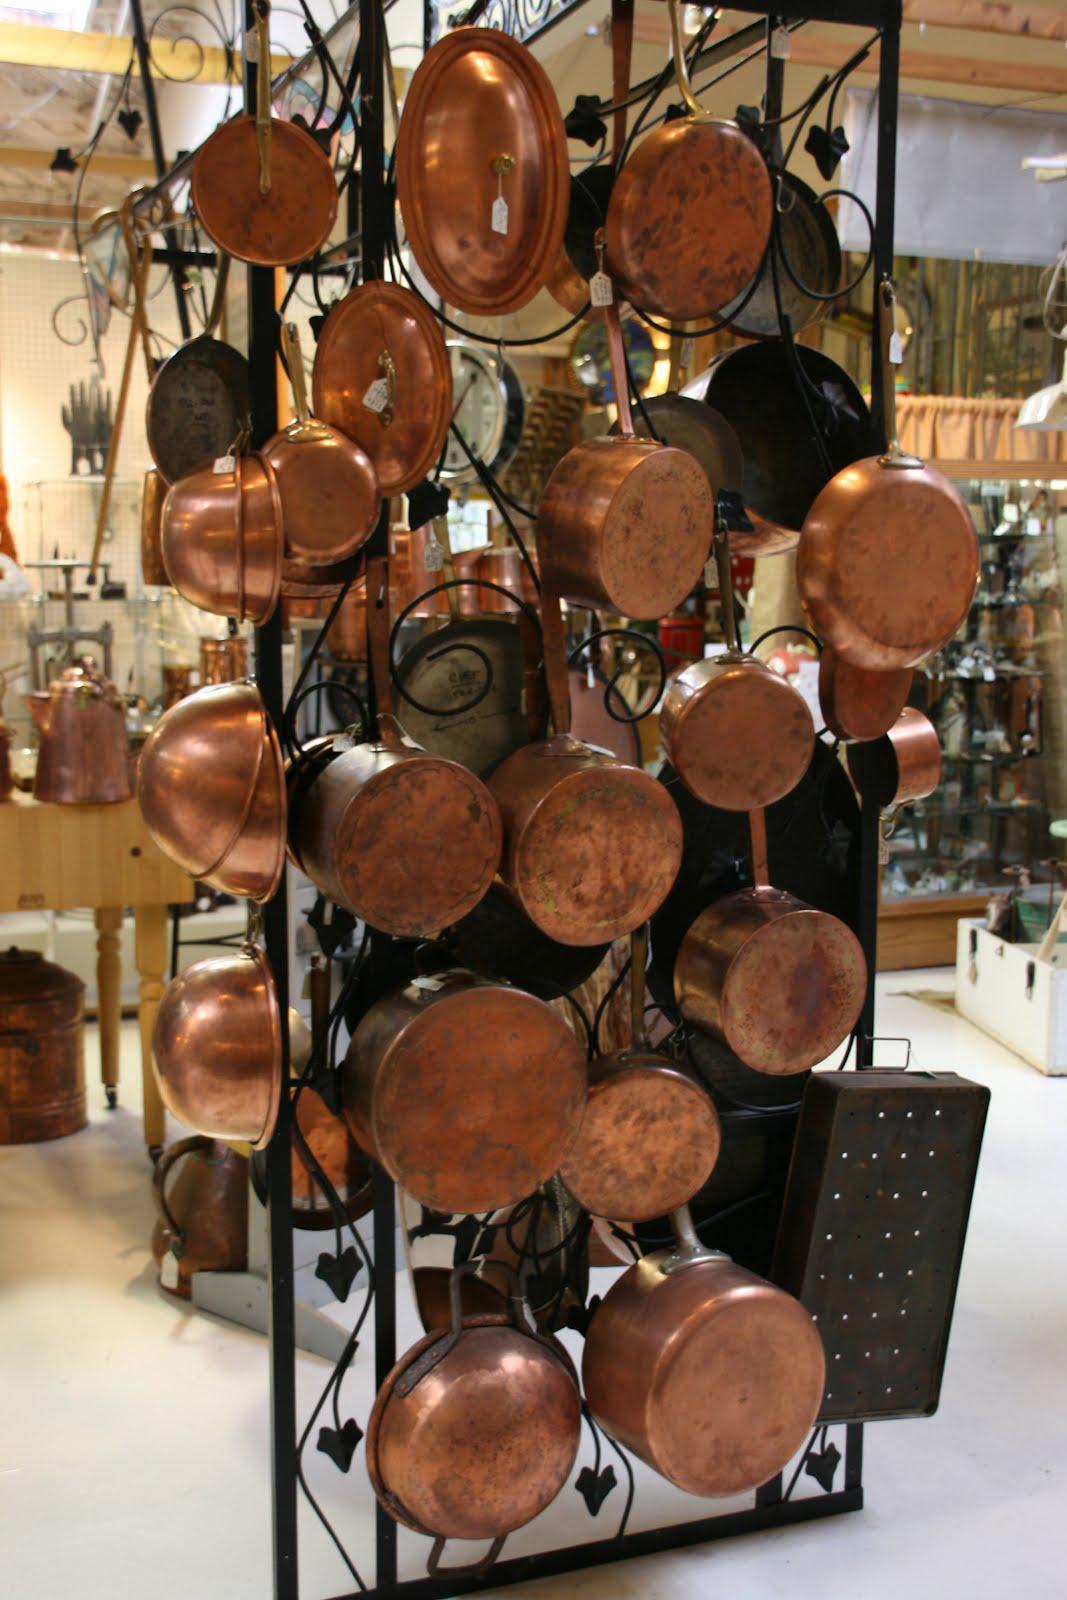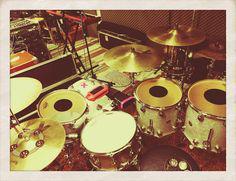The first image is the image on the left, the second image is the image on the right. For the images displayed, is the sentence "The right image shows a row of at least three white-topped drums with black around at least part of their sides and no cymbals." factually correct? Answer yes or no. No. 